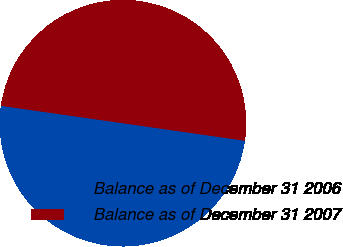Convert chart. <chart><loc_0><loc_0><loc_500><loc_500><pie_chart><fcel>Balance as of December 31 2006<fcel>Balance as of December 31 2007<nl><fcel>49.99%<fcel>50.01%<nl></chart> 